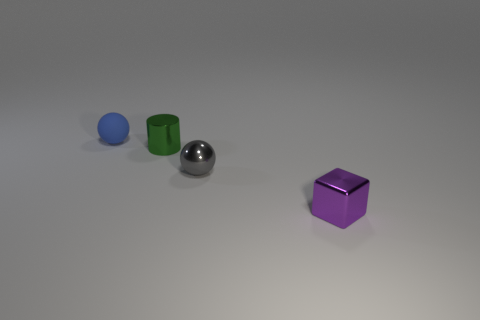Add 2 big blue matte cylinders. How many objects exist? 6 Subtract all cubes. How many objects are left? 3 Subtract 1 blue balls. How many objects are left? 3 Subtract all small blue things. Subtract all tiny green cylinders. How many objects are left? 2 Add 4 small blue objects. How many small blue objects are left? 5 Add 2 small blue rubber spheres. How many small blue rubber spheres exist? 3 